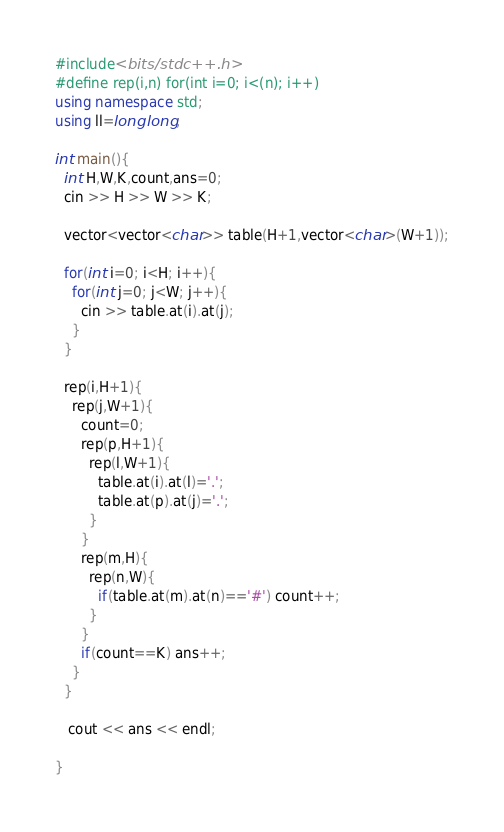Convert code to text. <code><loc_0><loc_0><loc_500><loc_500><_C++_>#include<bits/stdc++.h>
#define rep(i,n) for(int i=0; i<(n); i++)
using namespace std;
using ll=long long;

int main(){
  int H,W,K,count,ans=0;
  cin >> H >> W >> K;
  
  vector<vector<char>> table(H+1,vector<char>(W+1));
  
  for(int i=0; i<H; i++){
    for(int j=0; j<W; j++){
      cin >> table.at(i).at(j);
    }
  }
  
  rep(i,H+1){
    rep(j,W+1){
      count=0;
      rep(p,H+1){
        rep(l,W+1){
          table.at(i).at(l)='.';
          table.at(p).at(j)='.';
        }
      }
      rep(m,H){
        rep(n,W){
          if(table.at(m).at(n)=='#') count++;
        }
      }
      if(count==K) ans++;
    }
  }
      
   cout << ans << endl;
      
}    
</code> 